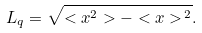Convert formula to latex. <formula><loc_0><loc_0><loc_500><loc_500>L _ { q } = \sqrt { < x ^ { 2 } > - < x > ^ { \, 2 } } .</formula> 